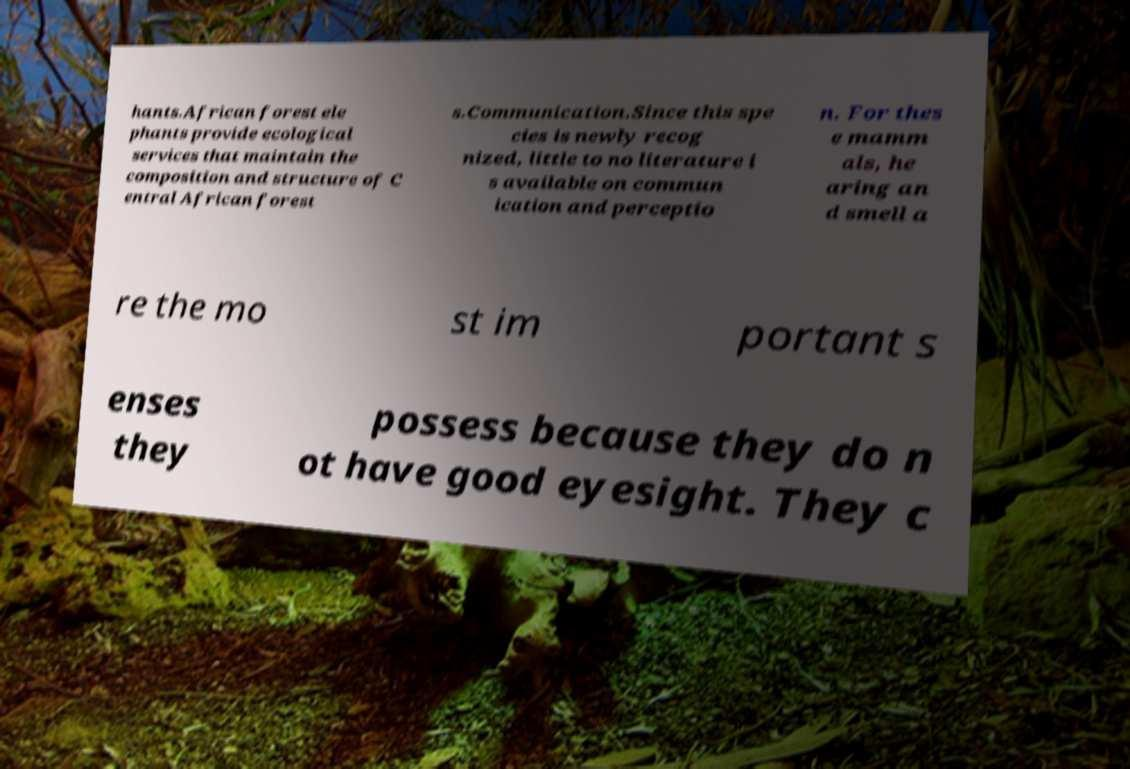Can you read and provide the text displayed in the image?This photo seems to have some interesting text. Can you extract and type it out for me? hants.African forest ele phants provide ecological services that maintain the composition and structure of C entral African forest s.Communication.Since this spe cies is newly recog nized, little to no literature i s available on commun ication and perceptio n. For thes e mamm als, he aring an d smell a re the mo st im portant s enses they possess because they do n ot have good eyesight. They c 